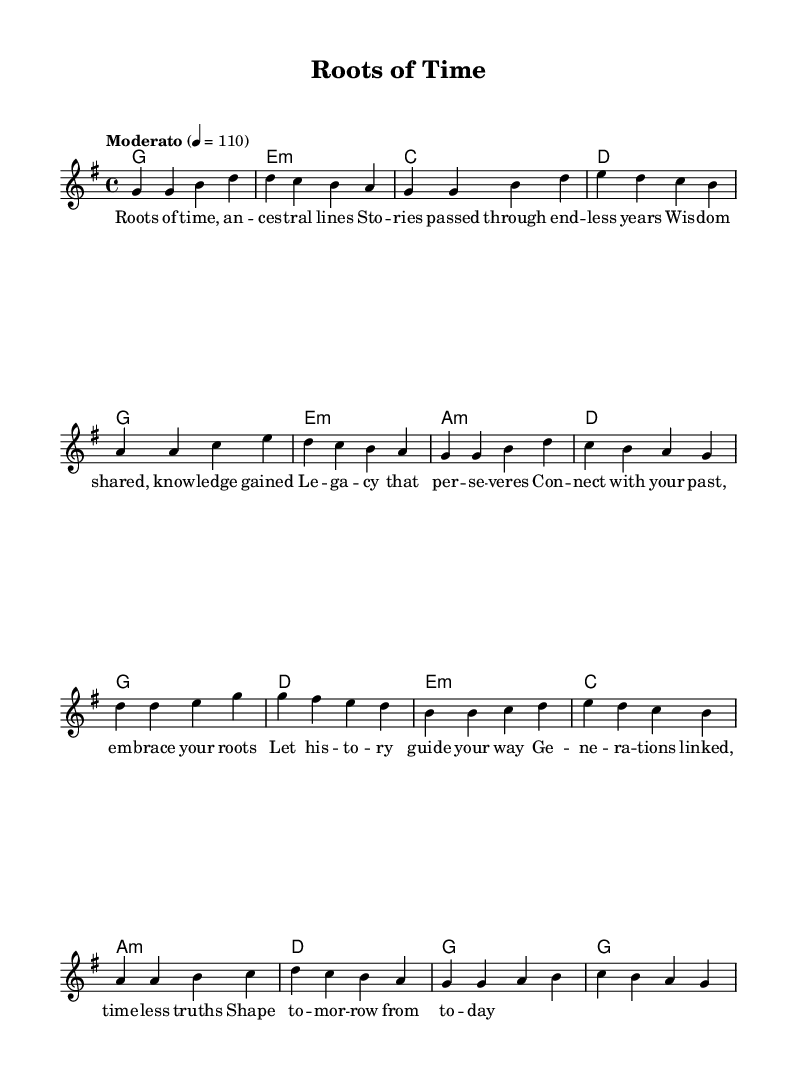What is the key signature of this music? The key signature displayed has one sharp, indicating it is in G major. This can be concluded by identifying the sharp sign in the key signature section.
Answer: G major What is the time signature of this music? The time signature shown in the music is 4/4, which indicates four beats per measure with the quarter note receiving one beat. This is observed in the notated time signature following the key signature.
Answer: 4/4 What is the tempo marking for this piece? The tempo marking indicates "Moderato" with a metronome marking of 110 beats per minute. This information can be found in the tempo section of the sheet music.
Answer: Moderato, 110 How many measures are in the verse section? The verse section consists of eight measures. Counting the individual measures from the start of the verse to the end confirms this total.
Answer: 8 How does the chorus begin melodically? The chorus begins melodically with the notes D, D, E, G, which are the first four notes of the chorus. This can be identified by looking at the melody line in the specified section.
Answer: D, D, E, G What is the main theme conveyed in the lyrics? The main theme conveyed in the lyrics relates to connecting with the past and embracing one's roots, as expressed in phrases like "connect with your past" and "embrace your roots". This can be deduced from both the verse and chorus lyrics.
Answer: Legacy What is the relationship between the verse and the chorus regarding musical structure? The verse and chorus reflect a contrasting musical structure, with the verse presenting a more narrative storytelling approach, while the chorus introduces a more reflective tone that emphasizes connection and legacy. This can be understood by analyzing the themes and emotions expressed within each section.
Answer: Contrasting structure 